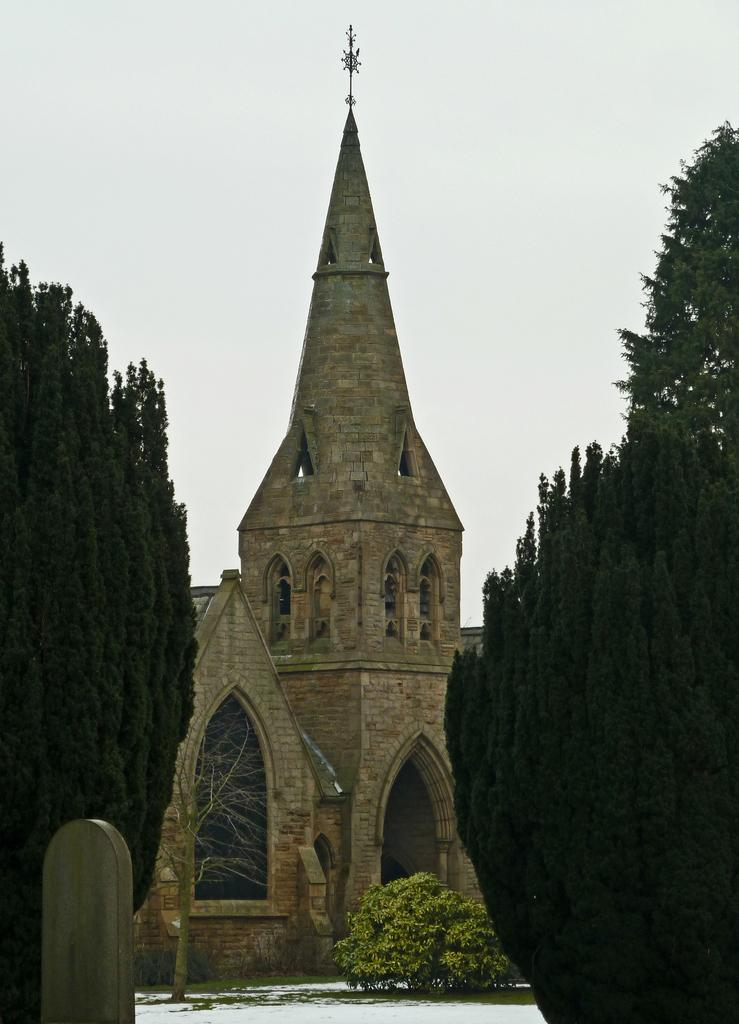What type of building can be seen in the image? There is an old architecture building with arches in the image. What other elements are present in the image besides the building? There are plants and trees in the image. What is visible at the top of the image? The sky is visible at the top of the image. Can you tell me how the beetle is controlling the spark in the image? There is no beetle or spark present in the image. 